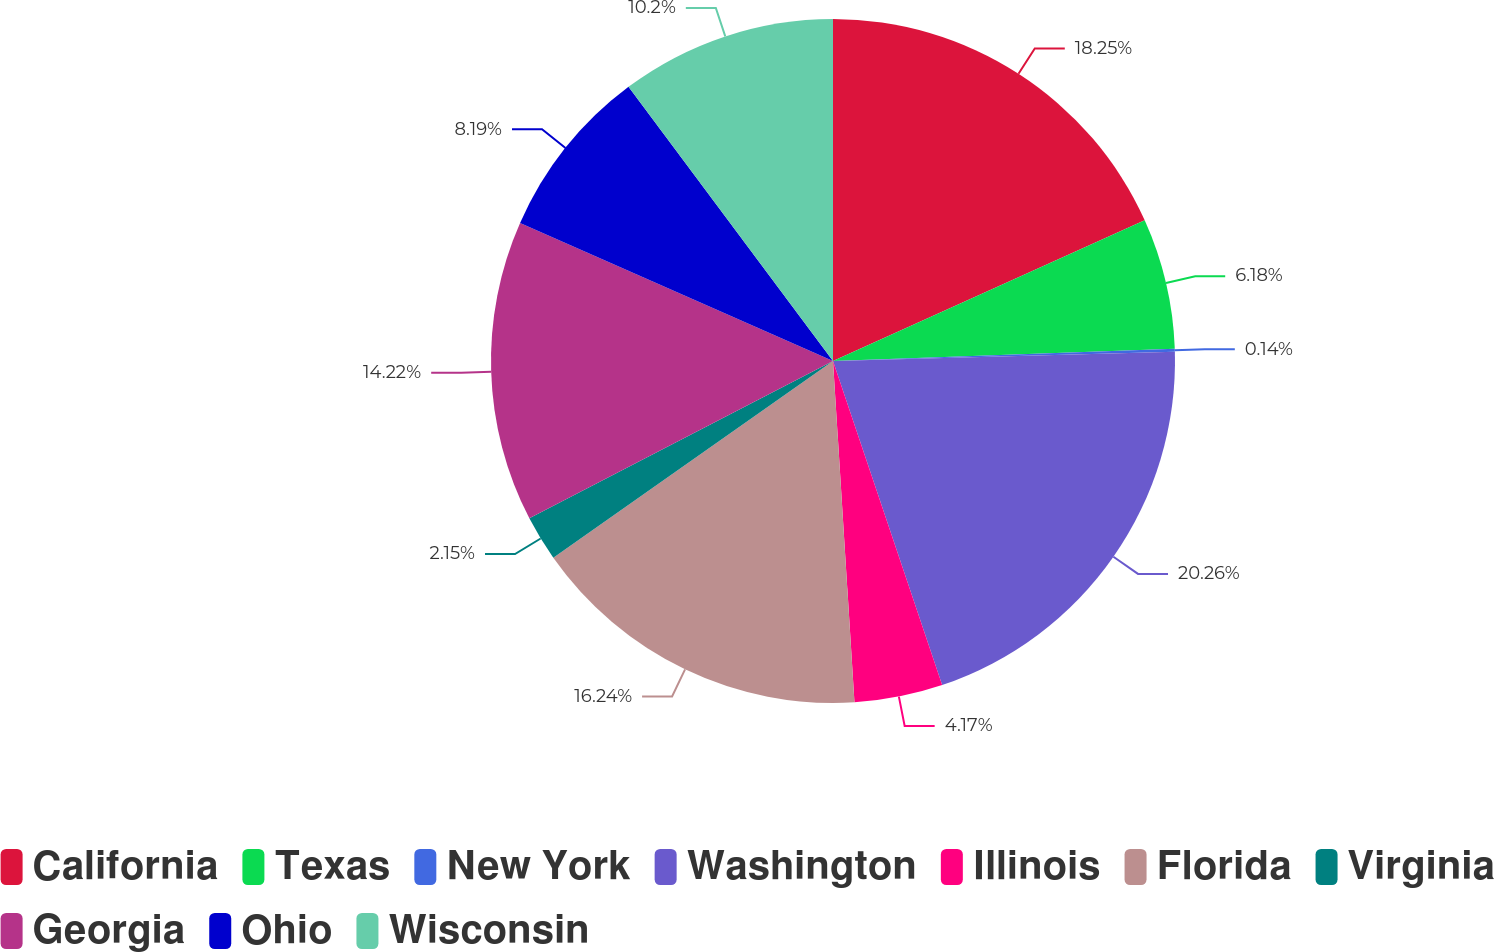Convert chart. <chart><loc_0><loc_0><loc_500><loc_500><pie_chart><fcel>California<fcel>Texas<fcel>New York<fcel>Washington<fcel>Illinois<fcel>Florida<fcel>Virginia<fcel>Georgia<fcel>Ohio<fcel>Wisconsin<nl><fcel>18.25%<fcel>6.18%<fcel>0.14%<fcel>20.26%<fcel>4.17%<fcel>16.24%<fcel>2.15%<fcel>14.22%<fcel>8.19%<fcel>10.2%<nl></chart> 